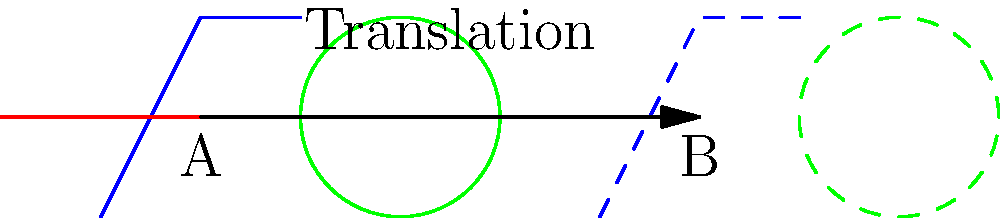In designing a playground layout for imaginative play, you decide to create a mirror image of the existing play area. If the slide (blue), seesaw (red), and sandbox (green) are translated 5 units to the right, what type of transformation is applied to move the playground from position A to position B? To solve this problem, let's analyze the transformation step-by-step:

1. Observe the original playground elements at position A:
   - Slide (blue)
   - Seesaw (red)
   - Sandbox (green)

2. Notice the transformed playground elements at position B:
   - All shapes maintain their original size and orientation
   - All shapes have moved 5 units to the right

3. Key characteristics of the transformation:
   - The distance between corresponding points in A and B is constant (5 units)
   - The direction of movement is consistent (to the right)
   - Shapes retain their size and orientation

4. In geometry, a transformation that moves all points in a figure the same distance in the same direction is called a translation.

5. The arrow in the diagram represents this translation, moving the playground 5 units to the right.

Therefore, the transformation applied to move the playground from position A to position B is a translation.
Answer: Translation 